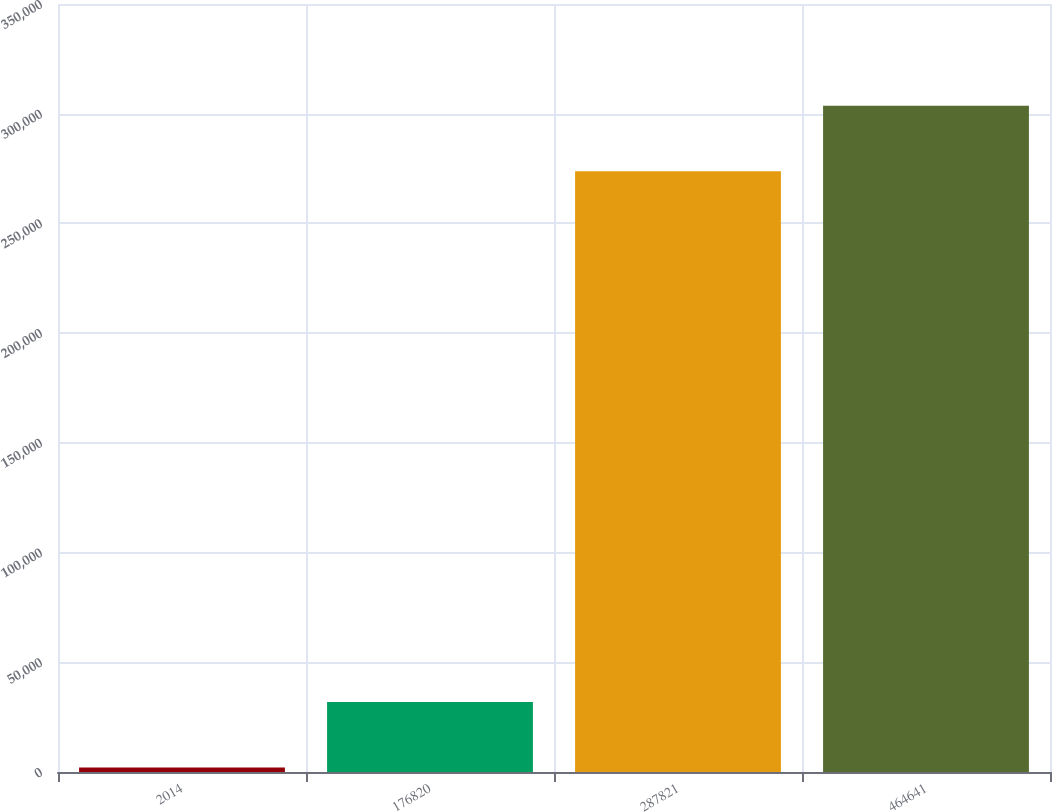<chart> <loc_0><loc_0><loc_500><loc_500><bar_chart><fcel>2014<fcel>176820<fcel>287821<fcel>464641<nl><fcel>2013<fcel>31881<fcel>273805<fcel>303673<nl></chart> 